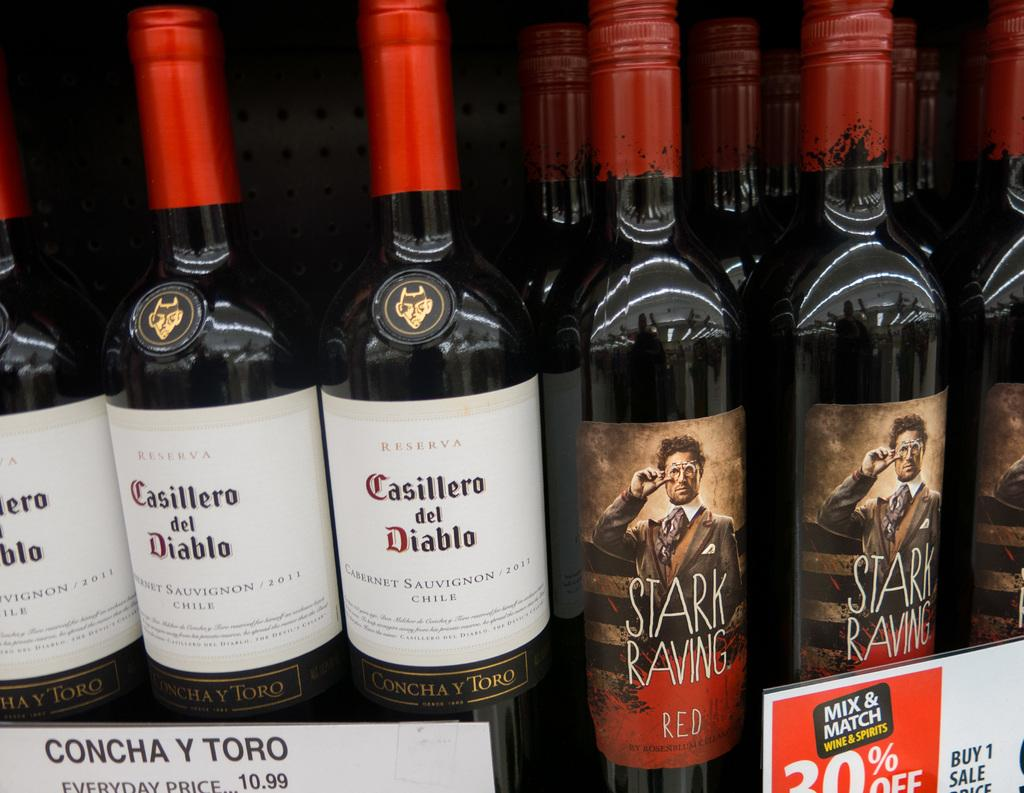Provide a one-sentence caption for the provided image. A display of wines with two different brands that are Casillero del diablo and Starving Raving. 